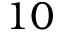Convert formula to latex. <formula><loc_0><loc_0><loc_500><loc_500>1 0</formula> 